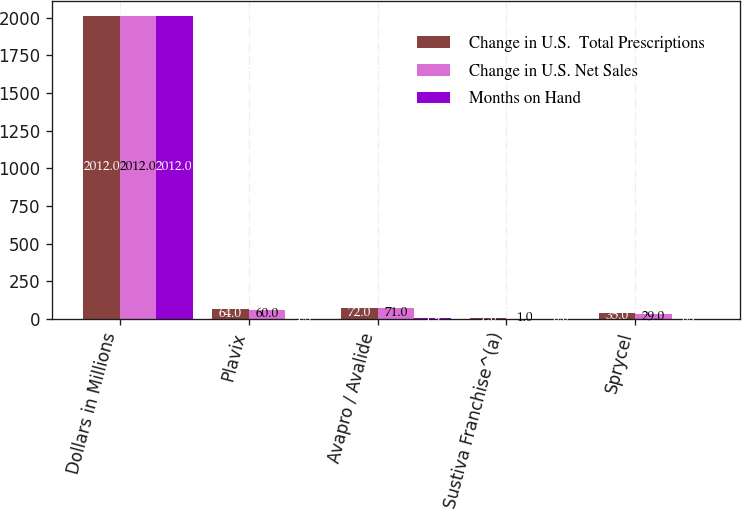Convert chart to OTSL. <chart><loc_0><loc_0><loc_500><loc_500><stacked_bar_chart><ecel><fcel>Dollars in Millions<fcel>Plavix<fcel>Avapro / Avalide<fcel>Sustiva Franchise^(a)<fcel>Sprycel<nl><fcel>Change in U.S.  Total Prescriptions<fcel>2012<fcel>64<fcel>72<fcel>7<fcel>35<nl><fcel>Change in U.S. Net Sales<fcel>2012<fcel>60<fcel>71<fcel>1<fcel>29<nl><fcel>Months on Hand<fcel>2012<fcel>1.3<fcel>1.9<fcel>0.6<fcel>0.7<nl></chart> 